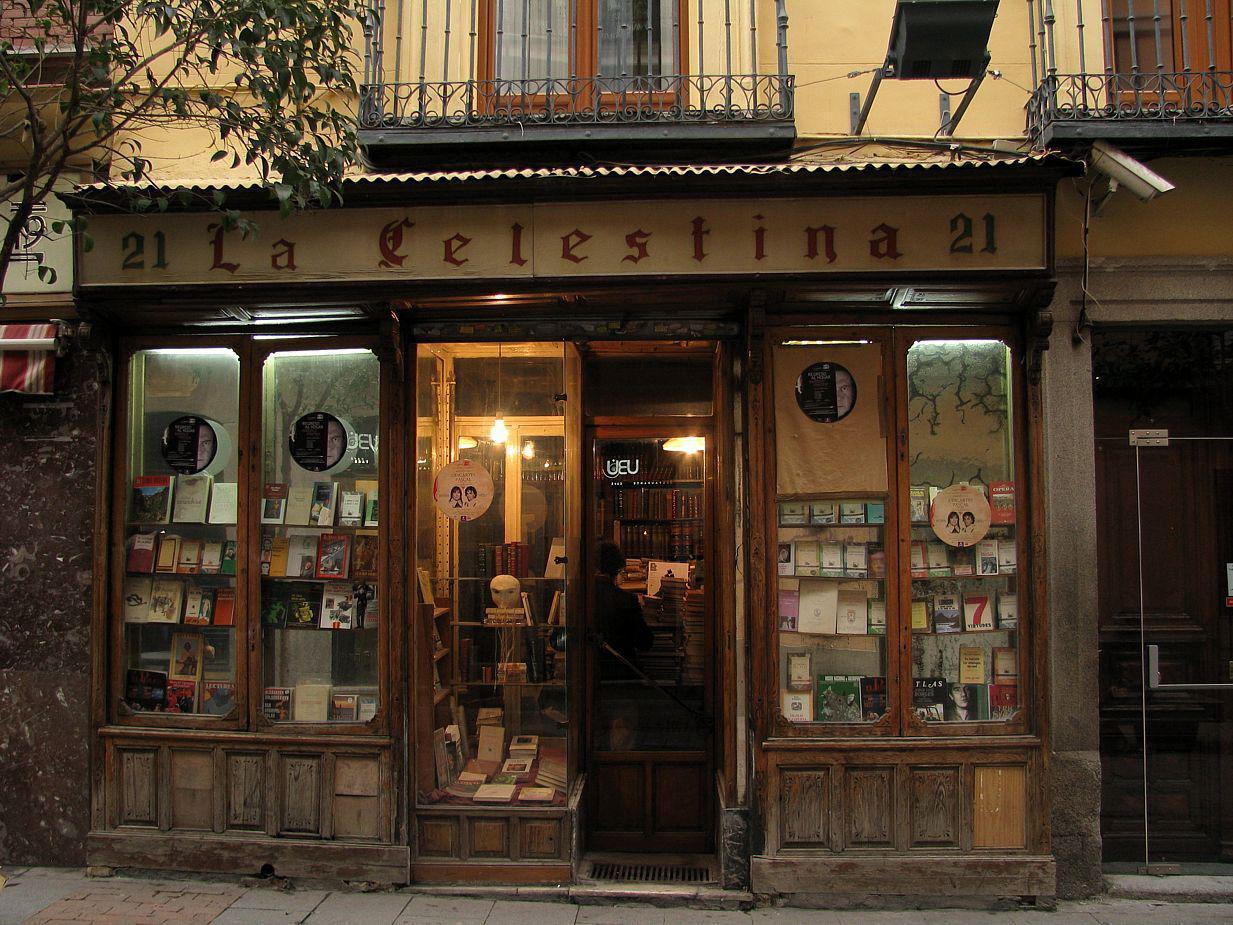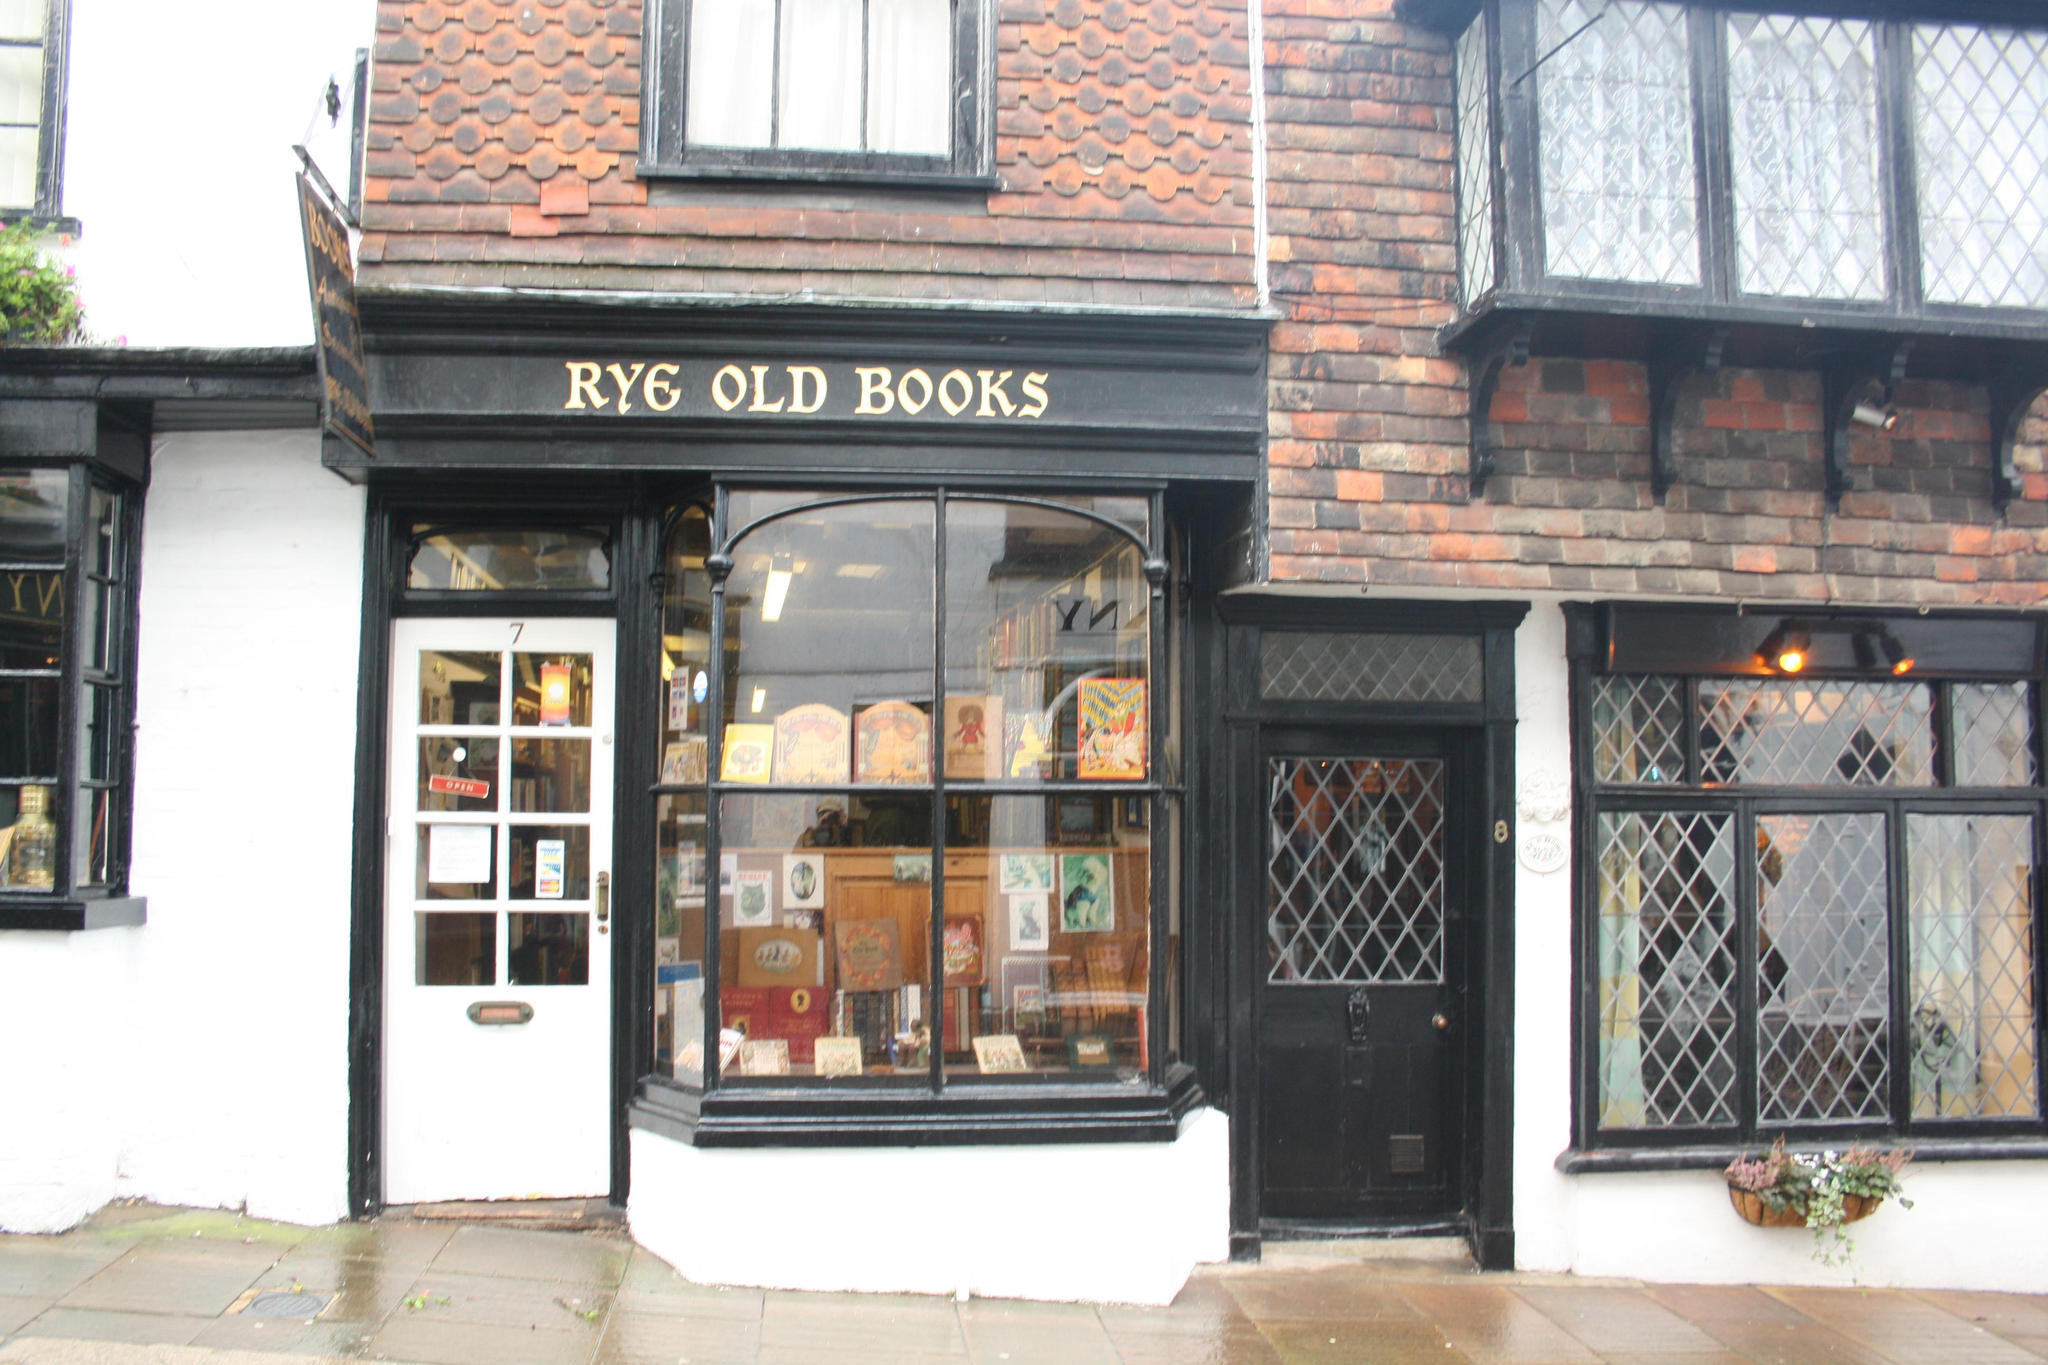The first image is the image on the left, the second image is the image on the right. Analyze the images presented: Is the assertion "The right image contains an outside view of a storefront." valid? Answer yes or no. Yes. The first image is the image on the left, the second image is the image on the right. For the images displayed, is the sentence "In this book store there is at least one person looking at  books from the shelve." factually correct? Answer yes or no. No. 